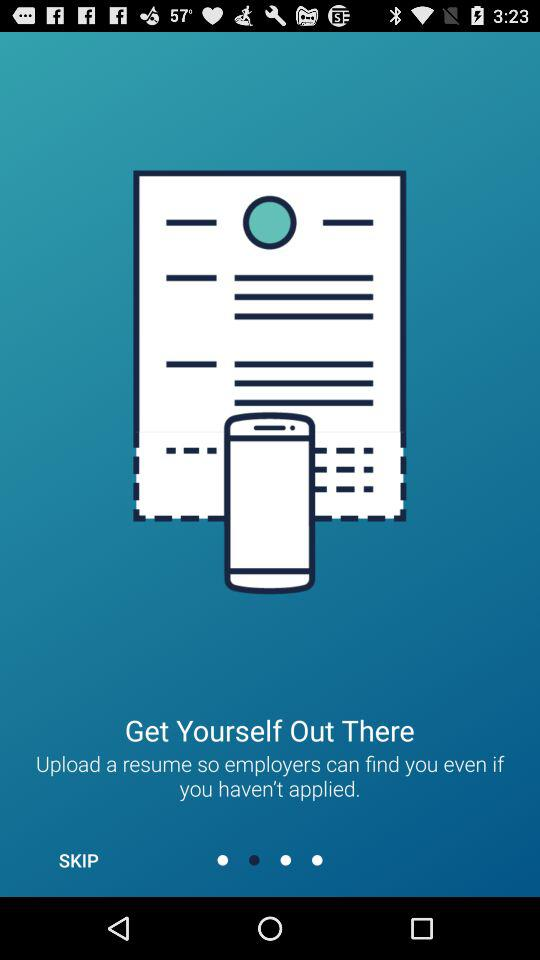What to upload so that employers can find you? You can upload a resume so that employers can find you. 